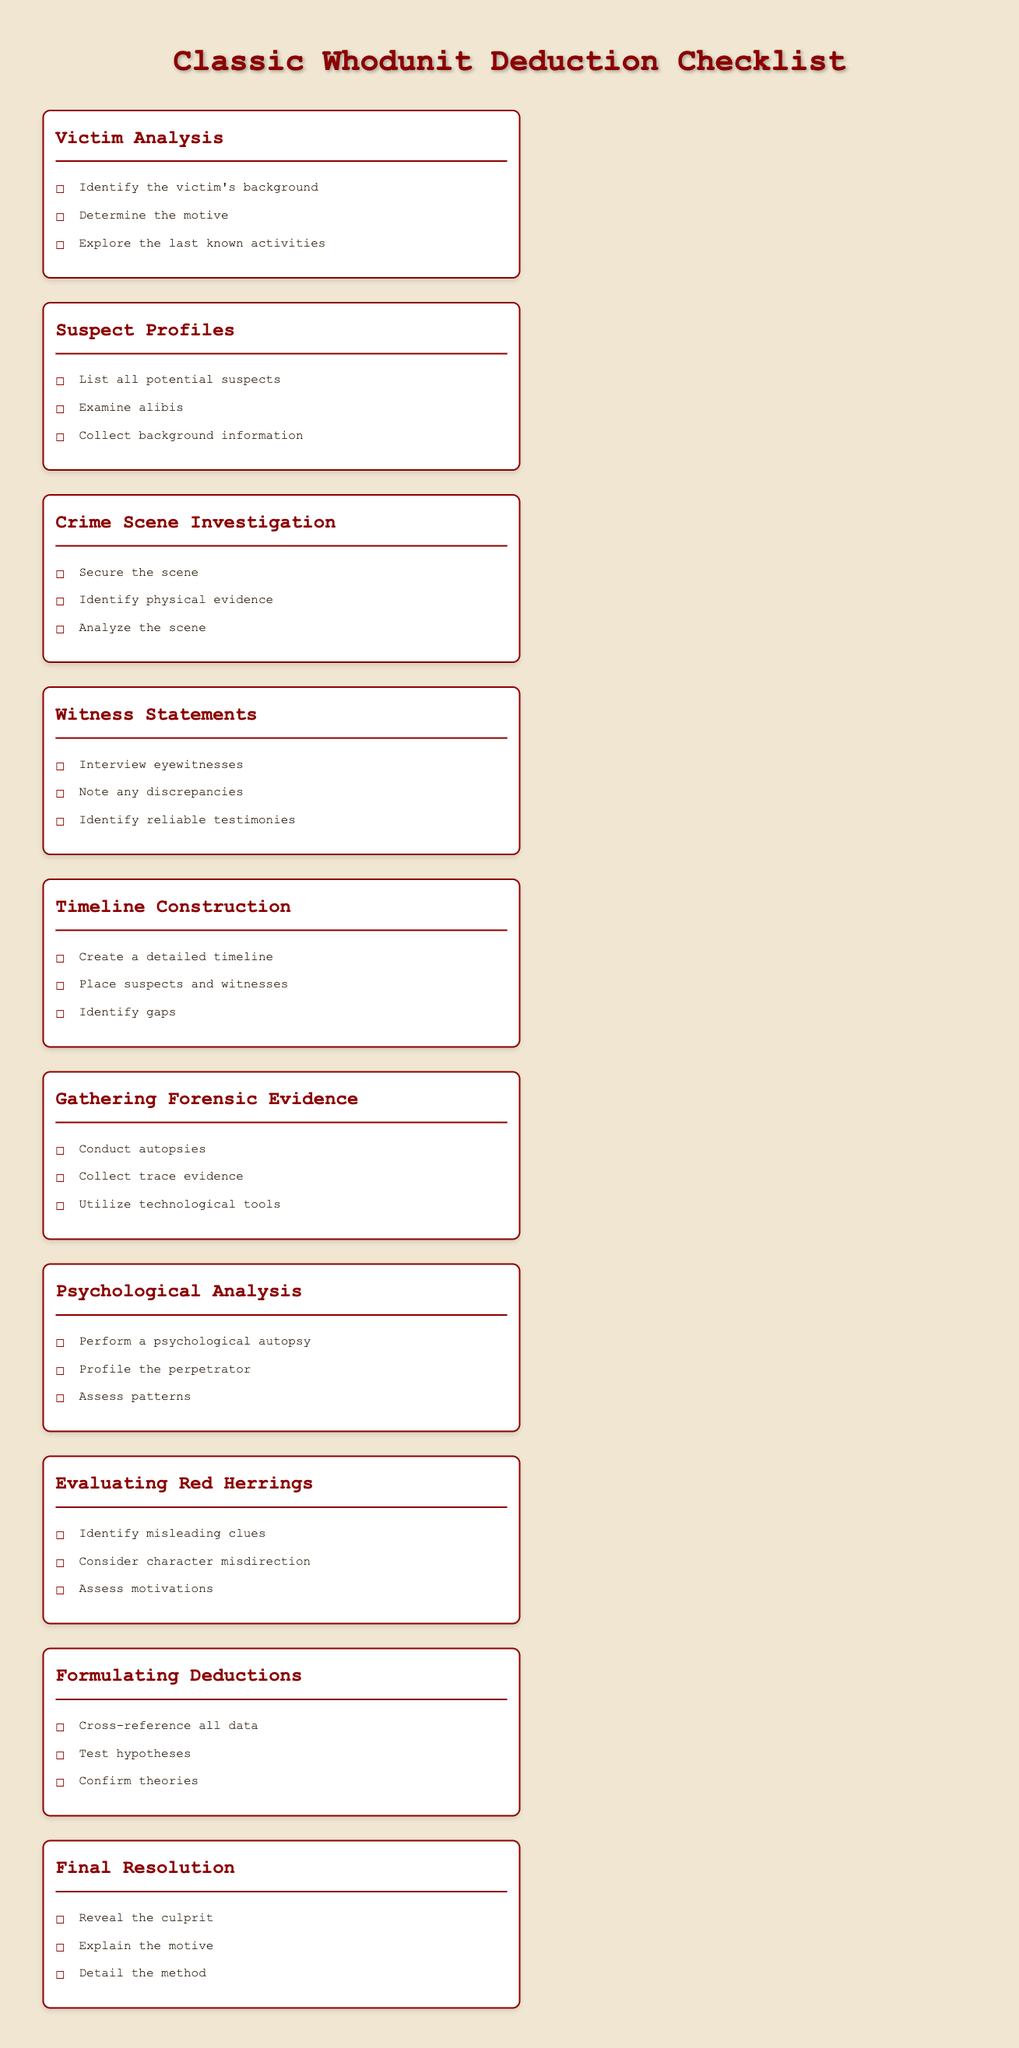What is the first section listed in the checklist? The first section is the first h2 header in the document concerning the checklist.
Answer: Victim Analysis How many sections are in the checklist? The total number of h2 headers in the checklist indicates the different sections covered.
Answer: Ten What is one of the tasks under "Suspect Profiles"? This looks for a specific item listed in the "Suspect Profiles" section, which is an h2 header with associated tasks.
Answer: Examine alibis Which section addresses misleading clues? This refers to a specific section that discusses the concept of misleading clues in the context of the checklist.
Answer: Evaluating Red Herrings What type of analysis is performed in the "Psychological Analysis" section? This question focuses on identifying the specific type of analysis mentioned in the relevant section header.
Answer: Psychological autopsy How many tasks are listed under "Gathering Forensic Evidence"? The total number of items (li elements) under this section indicates how many tasks are included.
Answer: Three What is the purpose of the "Final Resolution" section? This seeks to summarize the objective of the last section of the checklist as stated in its tasks.
Answer: Reveal the culprit What should be created in the "Timeline Construction" section? This focuses on identifying what type of construction is emphasized in this section of the checklist.
Answer: Detailed timeline What method should be utilized in the "Gathering Forensic Evidence" section? This question seeks to find a method that is specifically recommended in the listed tasks for this section.
Answer: Utilize technological tools What is the objective of "Formulating Deductions"? This examines the aim of the tasks presented in the section focusing on deductions.
Answer: Confirm theories 